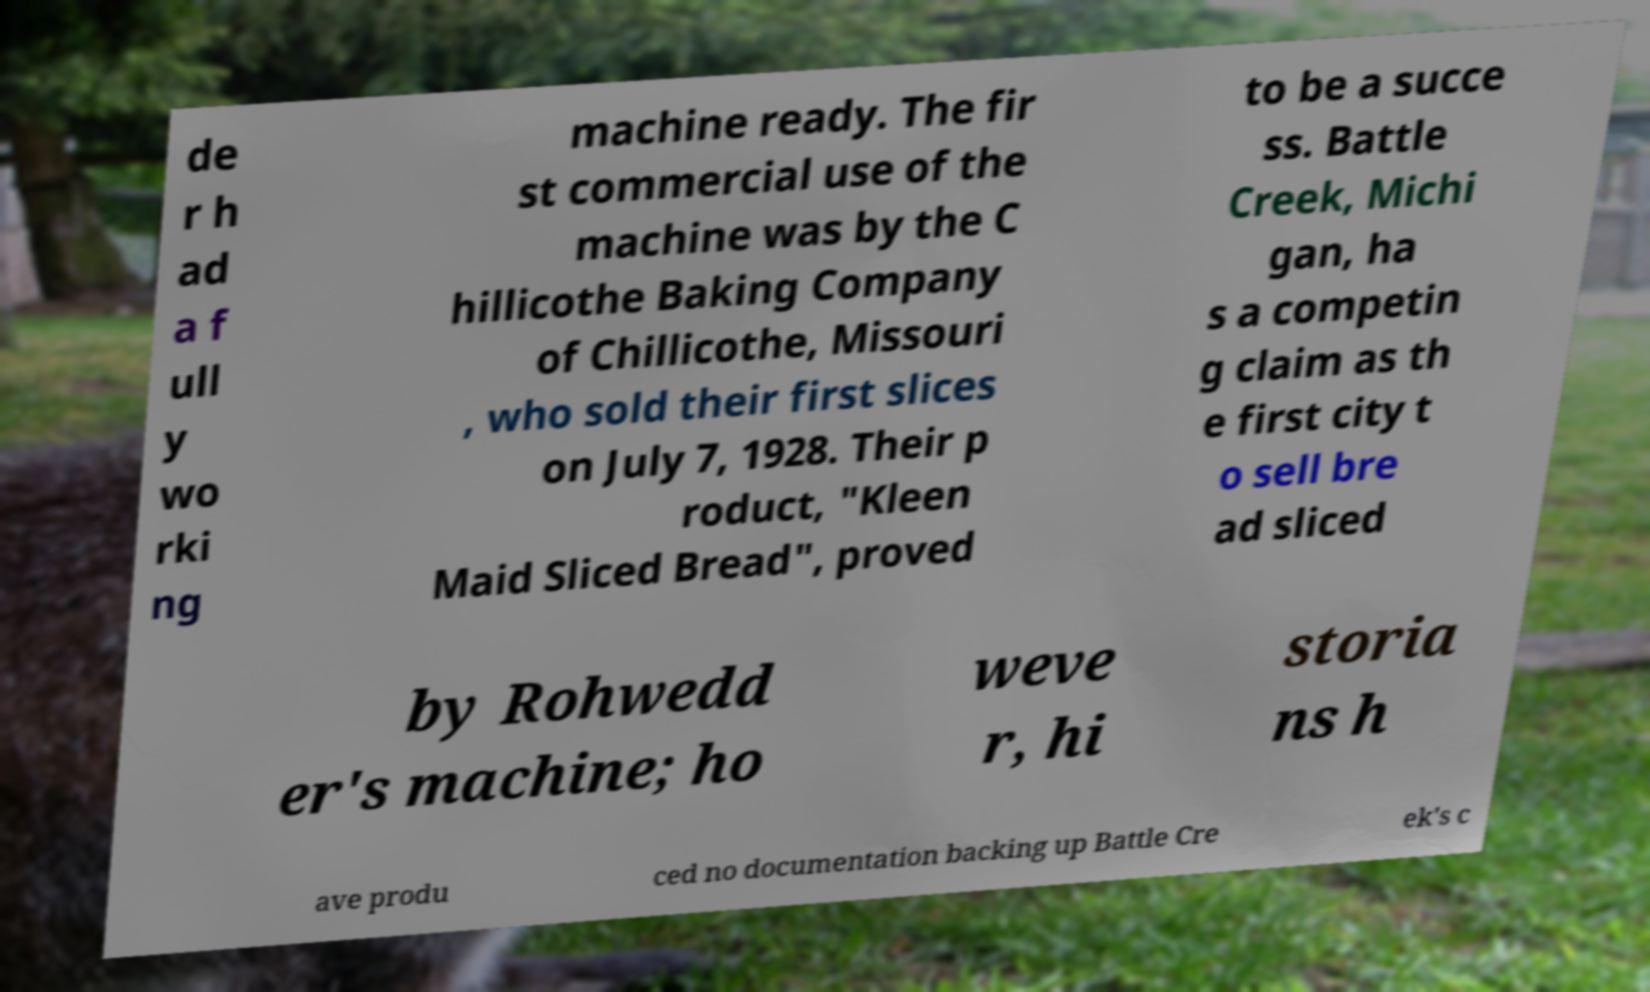There's text embedded in this image that I need extracted. Can you transcribe it verbatim? de r h ad a f ull y wo rki ng machine ready. The fir st commercial use of the machine was by the C hillicothe Baking Company of Chillicothe, Missouri , who sold their first slices on July 7, 1928. Their p roduct, "Kleen Maid Sliced Bread", proved to be a succe ss. Battle Creek, Michi gan, ha s a competin g claim as th e first city t o sell bre ad sliced by Rohwedd er's machine; ho weve r, hi storia ns h ave produ ced no documentation backing up Battle Cre ek's c 